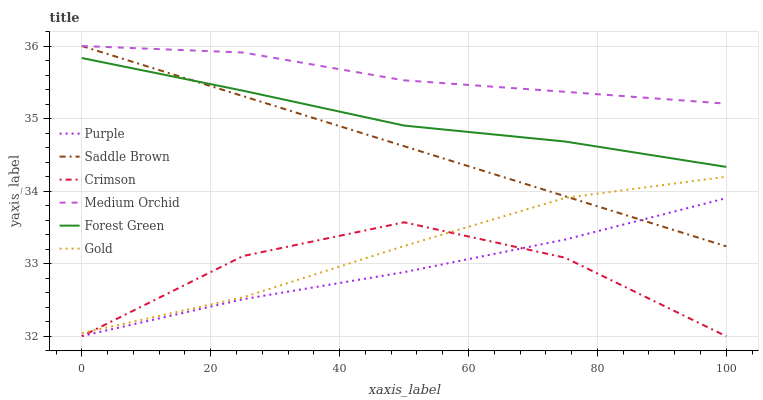Does Medium Orchid have the minimum area under the curve?
Answer yes or no. No. Does Purple have the maximum area under the curve?
Answer yes or no. No. Is Purple the smoothest?
Answer yes or no. No. Is Purple the roughest?
Answer yes or no. No. Does Purple have the lowest value?
Answer yes or no. No. Does Purple have the highest value?
Answer yes or no. No. Is Purple less than Medium Orchid?
Answer yes or no. Yes. Is Medium Orchid greater than Forest Green?
Answer yes or no. Yes. Does Purple intersect Medium Orchid?
Answer yes or no. No. 